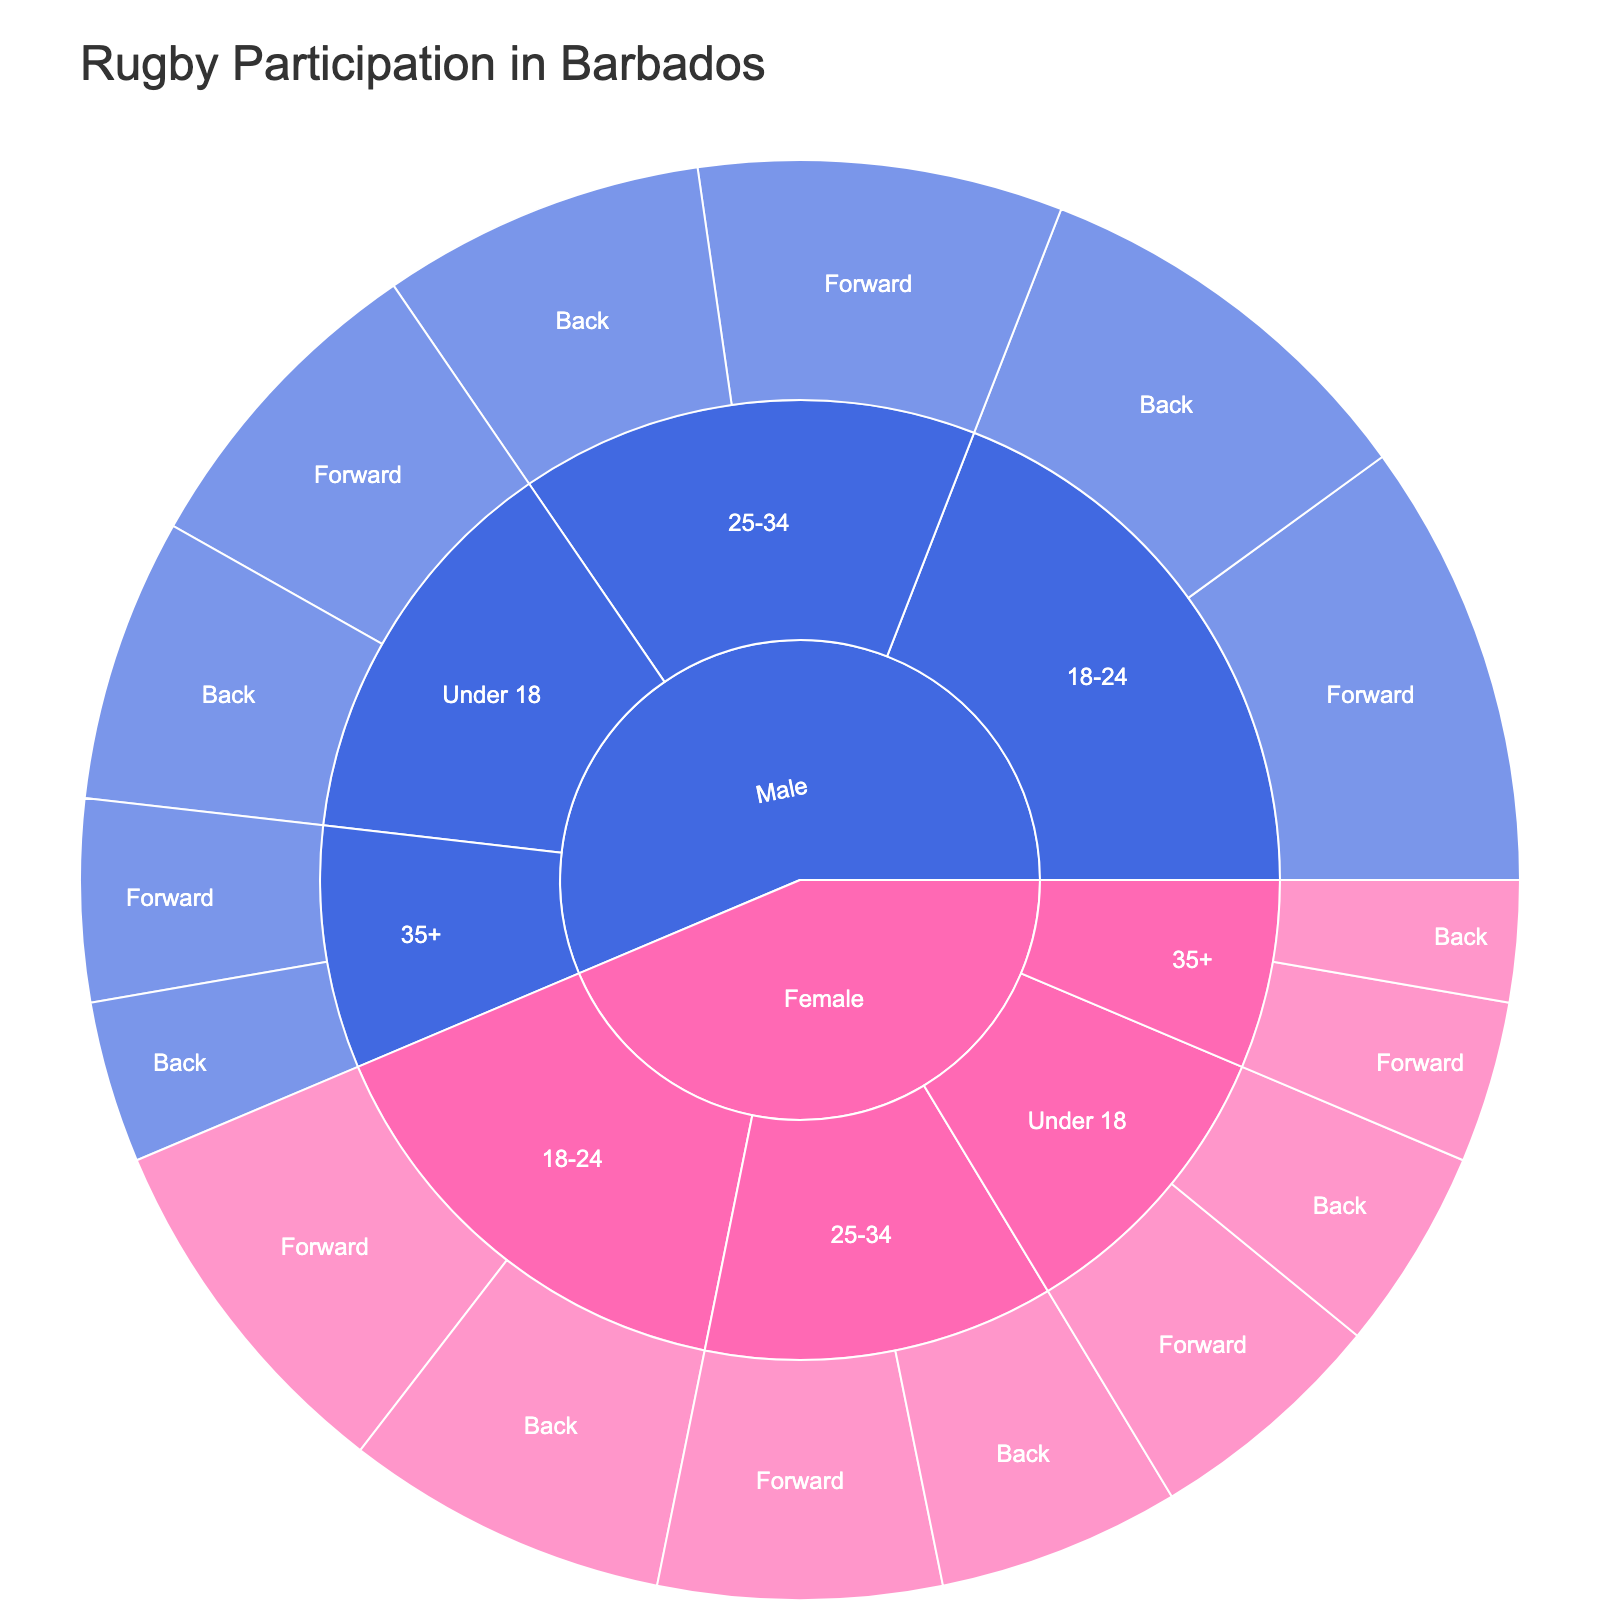What is the title of the Sunburst Plot? The title of the Sunburst Plot is usually displayed prominently at the top of the figure, which in this case is designed to be "Rugby Participation in Barbados".
Answer: Rugby Participation in Barbados How many age groups are represented in the plot for female players? Looking at the "Female" section of the Sunburst Plot, we see the major categories dividing it into age groups. Counting these segments, we find four: "Under 18", "18-24", "25-34", and "35+".
Answer: 4 Which gender has the most rugby players in the 18-24 age group? By examining the sections of the Sunburst Plot corresponding to the 18-24 age group for both genders, you notice that males have both larger segments visually and higher player counts for forwards (55) and backs (50). Summing these, males have 105 players compared to females’ total of 85 (45+40).
Answer: Male What are the total number of female rugby players aged 35 and above? Summing the number of players in the "Female" section for the "35+" age group, we find 20 forwards and 15 backs. Adding these gives 20 + 15 = 35.
Answer: 35 Which playing position has the highest participation across all age groups for males? Identifying the largest segment among the "Male" sections in the Sunburst Plot, specifically the divisions by playing positions, it'll be the 18-24 forwards with 55 players, the largest count for any position across all age groups.
Answer: Forward How does the participation of forwards compare between the 25-34 age group for males and females? For the 25-34 age group, male forwards account for 45 players while female forwards account for 35 players. Comparing these numbers, the male forwards are 10 players higher than the female forwards.
Answer: 10 more players What is the gender distribution for the "Under 18" age group? Refer to the initial segments for the "Under 18" age group. For males: forwards (40) + backs (35) = 75 players; for females: forwards (30) + backs (25) = 55 players. Thus, males have 75 and females have 55 players.
Answer: Males: 75; Females: 55 Among players aged 25-34, which gender has more players in the back position? Examining the corresponding segments in the Sunburst Plot for the back position among 25-34-year-olds, males have 40 players while females have 30 players. Comparing these counts, males have more backs.
Answer: Male What is the total number of rugby players shown in the plot? Summing all the "players" values across the entire dataset: Female (190) + Male (250) yields a total participation of 440 players.
Answer: 440 In the 18-24 age group, which playing position has more representation for females? Within the 18-24 age group in the "Female" section, comparing "Forward" (45) and "Back" (40) positions, forwards have a slightly higher player count.
Answer: Forward 